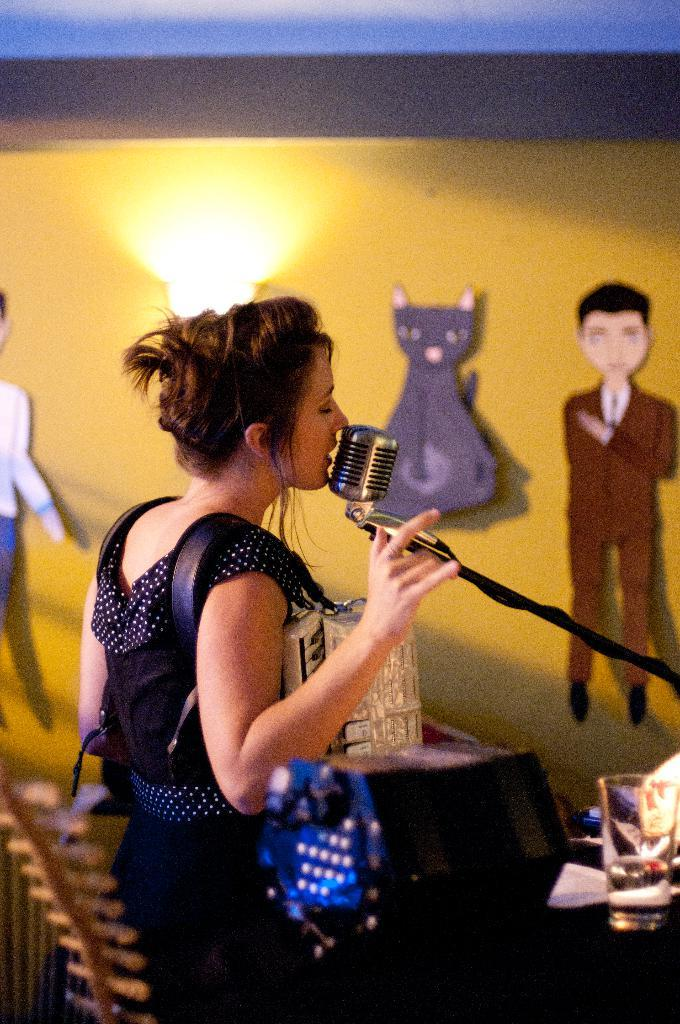What is happening in the room in the image? There is a woman singing on a microphone in the room. Can you describe the woman in the image? The image only shows a woman singing on a microphone, so we cannot provide a detailed description of her appearance. What is on the wall in the image? There is a painting of a cat and a pan on the wall in the image. What type of mark can be seen on the wall in the image? There is no mark visible on the wall in the image; it only features a painting of a cat and a pan. 